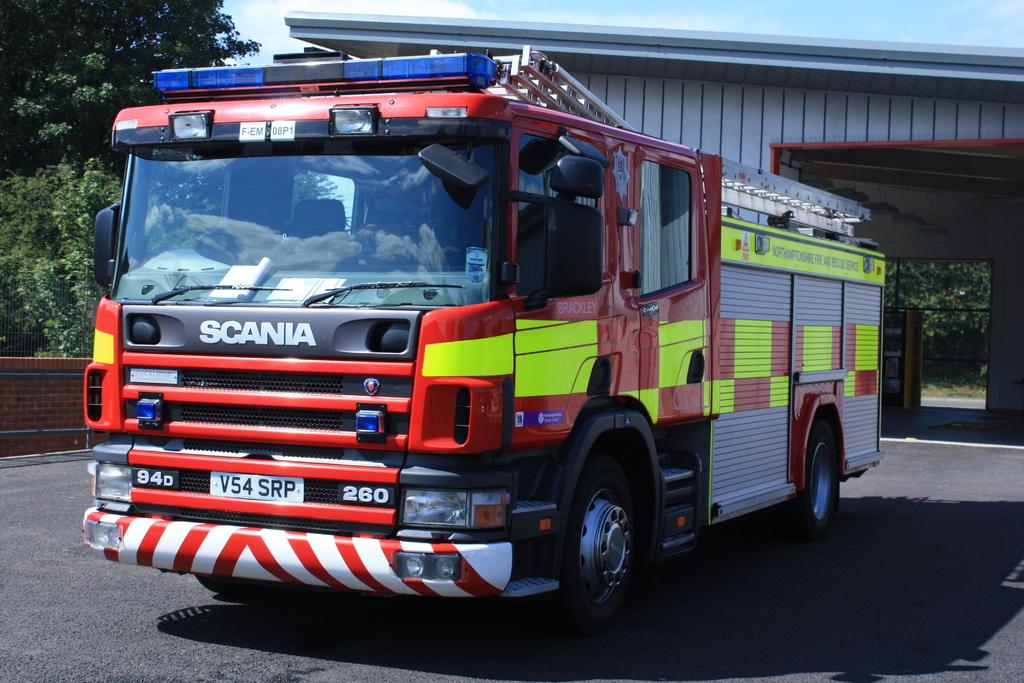What vehicle is present on the road in the image? There is a fire engine on the road in the image. What type of vegetation is on the left side of the image? There are trees on the left side of the image. What type of building can be seen in the background of the image? There appears to be a fire station in the background of the image. How would you describe the sky in the image? The sky is blue and cloudy in the image. What type of voice can be heard coming from the fire engine in the image? There is no voice coming from the fire engine in the image, as it is a vehicle and not capable of producing sound in this context. 